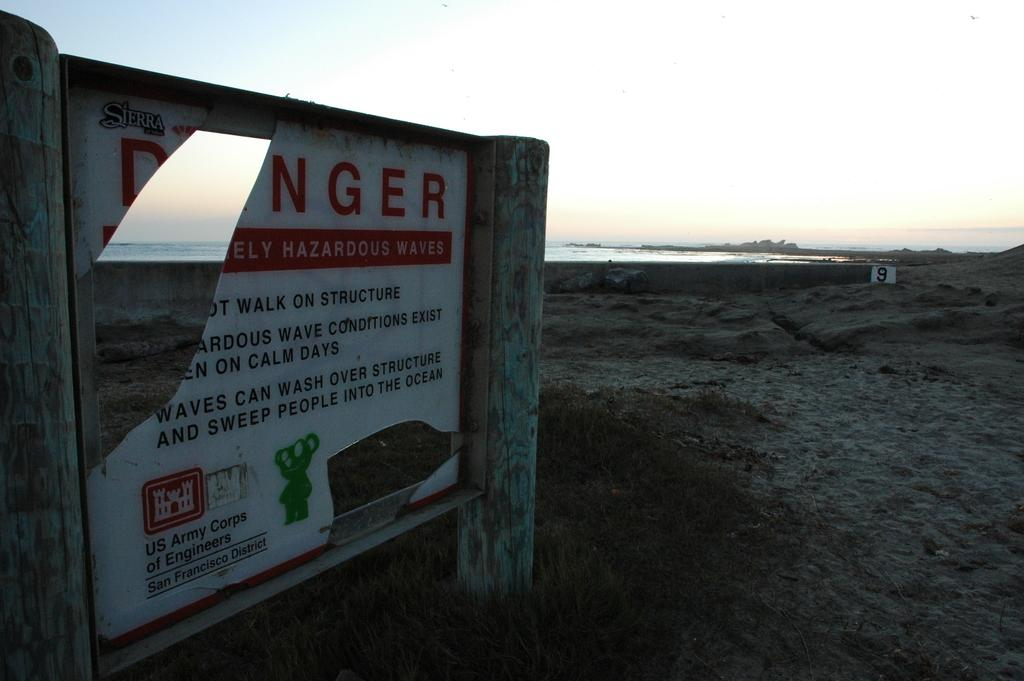What is the main object in the image? There is an advertisement board in the image. What can be seen in the background of the image? The sky, the ground, and grass are visible in the background of the image. What type of jam is being advertised on the board? There is no jam being advertised on the board; it is an advertisement board without any specific product mentioned. 